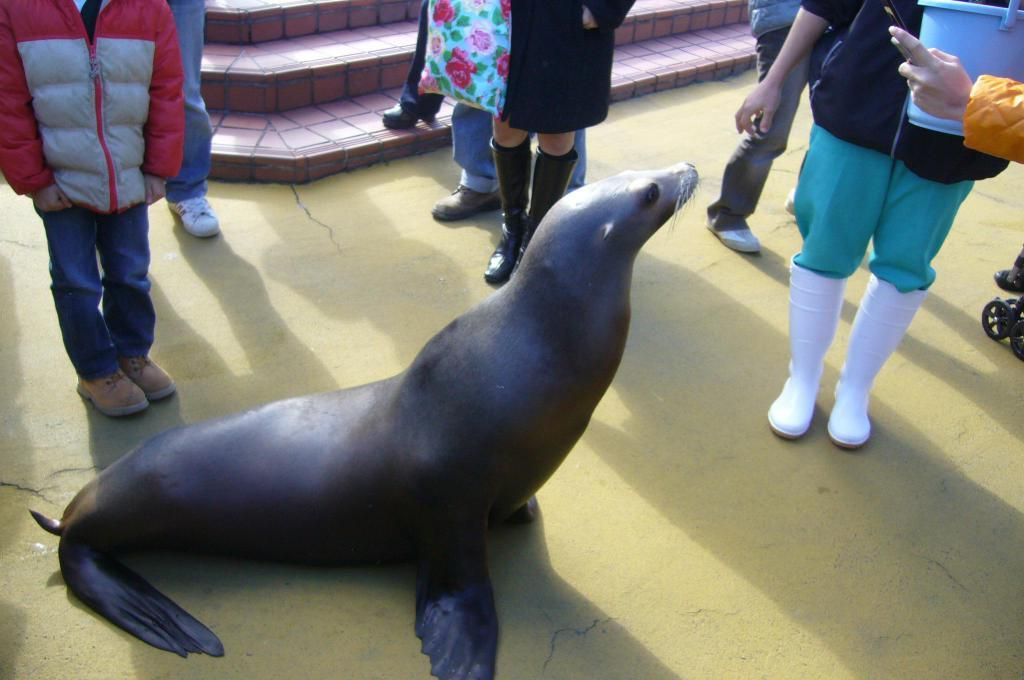What animal is at the bottom of the image? There is a seal at the bottom of the image. Can you describe the people in the background of the image? There are persons standing in the background of the image. What type of pain is the seal experiencing in the image? There is no indication in the image that the seal is experiencing any pain. 